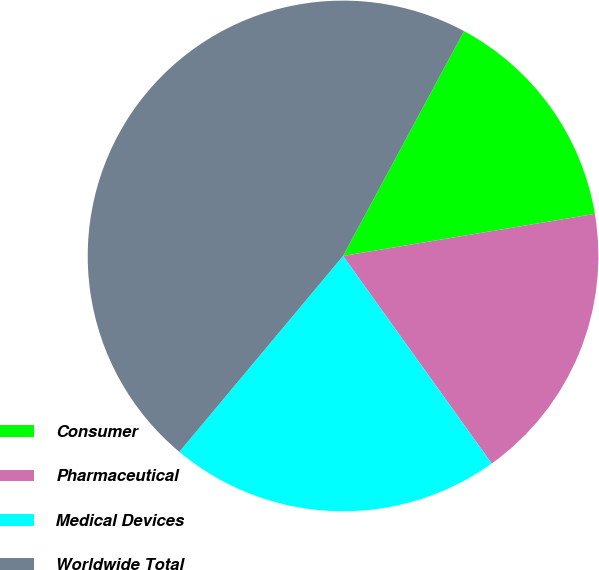<chart> <loc_0><loc_0><loc_500><loc_500><pie_chart><fcel>Consumer<fcel>Pharmaceutical<fcel>Medical Devices<fcel>Worldwide Total<nl><fcel>14.51%<fcel>17.74%<fcel>20.97%<fcel>46.78%<nl></chart> 